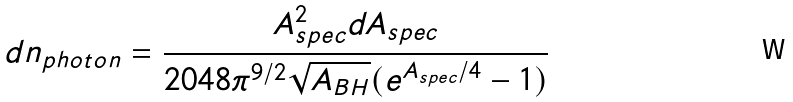<formula> <loc_0><loc_0><loc_500><loc_500>d n _ { p h o t o n } = \frac { A _ { s p e c } ^ { 2 } d A _ { s p e c } } { 2 0 4 8 \pi ^ { 9 / 2 } \sqrt { A _ { B H } } ( e ^ { A _ { s p e c } / 4 } - 1 ) }</formula> 